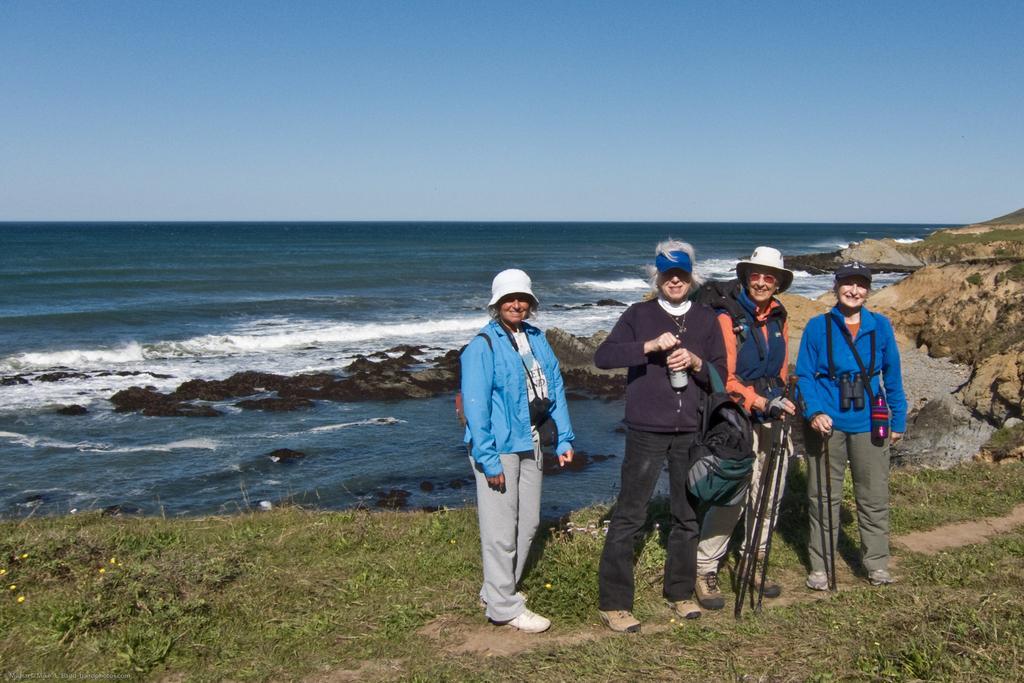Could you give a brief overview of what you see in this image? Here in this picture there are four ladies standing. They are wearing caps on their heads. And the lady with blue color jacket is hanging a camera around her neck. And at the background there is a beach. And the blue sky on the top. There are small hills on the right corner. And a grass at the bottom. 